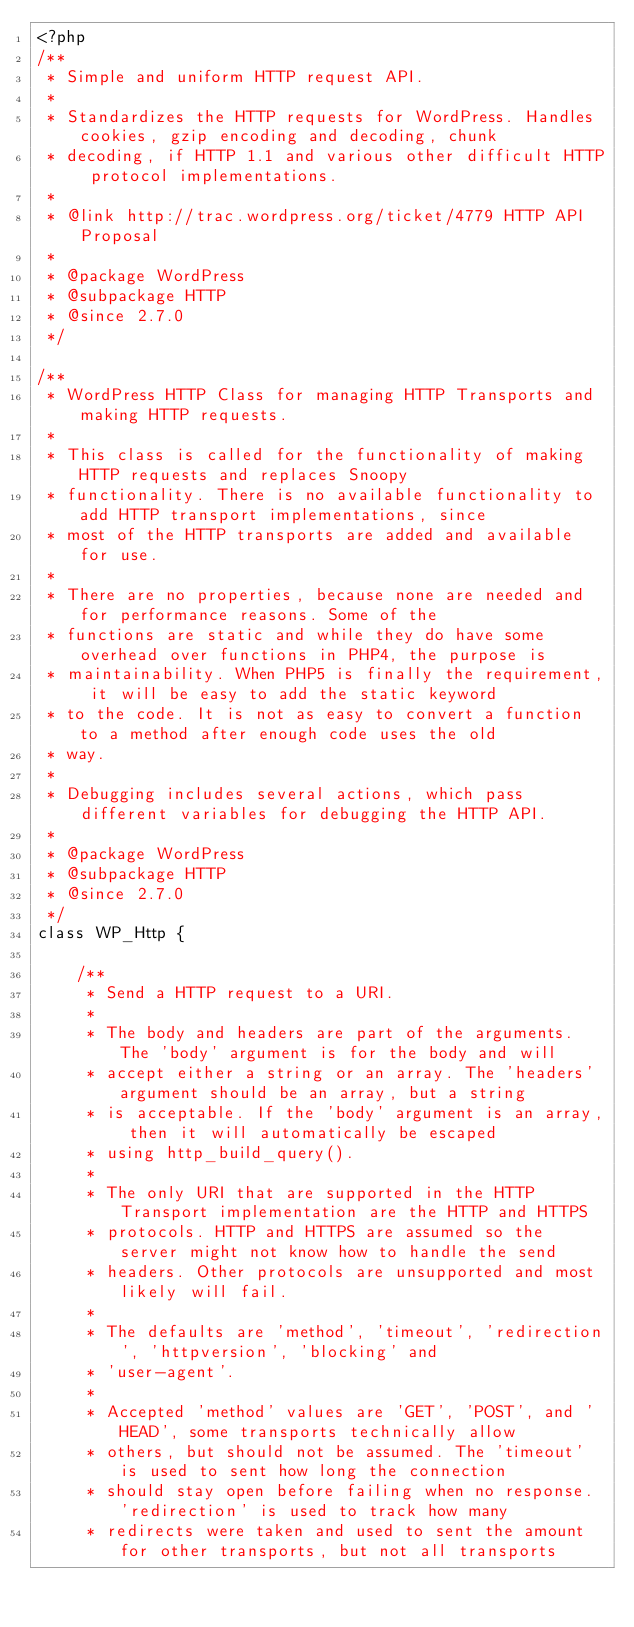<code> <loc_0><loc_0><loc_500><loc_500><_PHP_><?php
/**
 * Simple and uniform HTTP request API.
 *
 * Standardizes the HTTP requests for WordPress. Handles cookies, gzip encoding and decoding, chunk
 * decoding, if HTTP 1.1 and various other difficult HTTP protocol implementations.
 *
 * @link http://trac.wordpress.org/ticket/4779 HTTP API Proposal
 *
 * @package WordPress
 * @subpackage HTTP
 * @since 2.7.0
 */

/**
 * WordPress HTTP Class for managing HTTP Transports and making HTTP requests.
 *
 * This class is called for the functionality of making HTTP requests and replaces Snoopy
 * functionality. There is no available functionality to add HTTP transport implementations, since
 * most of the HTTP transports are added and available for use.
 *
 * There are no properties, because none are needed and for performance reasons. Some of the
 * functions are static and while they do have some overhead over functions in PHP4, the purpose is
 * maintainability. When PHP5 is finally the requirement, it will be easy to add the static keyword
 * to the code. It is not as easy to convert a function to a method after enough code uses the old
 * way.
 *
 * Debugging includes several actions, which pass different variables for debugging the HTTP API.
 *
 * @package WordPress
 * @subpackage HTTP
 * @since 2.7.0
 */
class WP_Http {

	/**
	 * Send a HTTP request to a URI.
	 *
	 * The body and headers are part of the arguments. The 'body' argument is for the body and will
	 * accept either a string or an array. The 'headers' argument should be an array, but a string
	 * is acceptable. If the 'body' argument is an array, then it will automatically be escaped
	 * using http_build_query().
	 *
	 * The only URI that are supported in the HTTP Transport implementation are the HTTP and HTTPS
	 * protocols. HTTP and HTTPS are assumed so the server might not know how to handle the send
	 * headers. Other protocols are unsupported and most likely will fail.
	 *
	 * The defaults are 'method', 'timeout', 'redirection', 'httpversion', 'blocking' and
	 * 'user-agent'.
	 *
	 * Accepted 'method' values are 'GET', 'POST', and 'HEAD', some transports technically allow
	 * others, but should not be assumed. The 'timeout' is used to sent how long the connection
	 * should stay open before failing when no response. 'redirection' is used to track how many
	 * redirects were taken and used to sent the amount for other transports, but not all transports</code> 